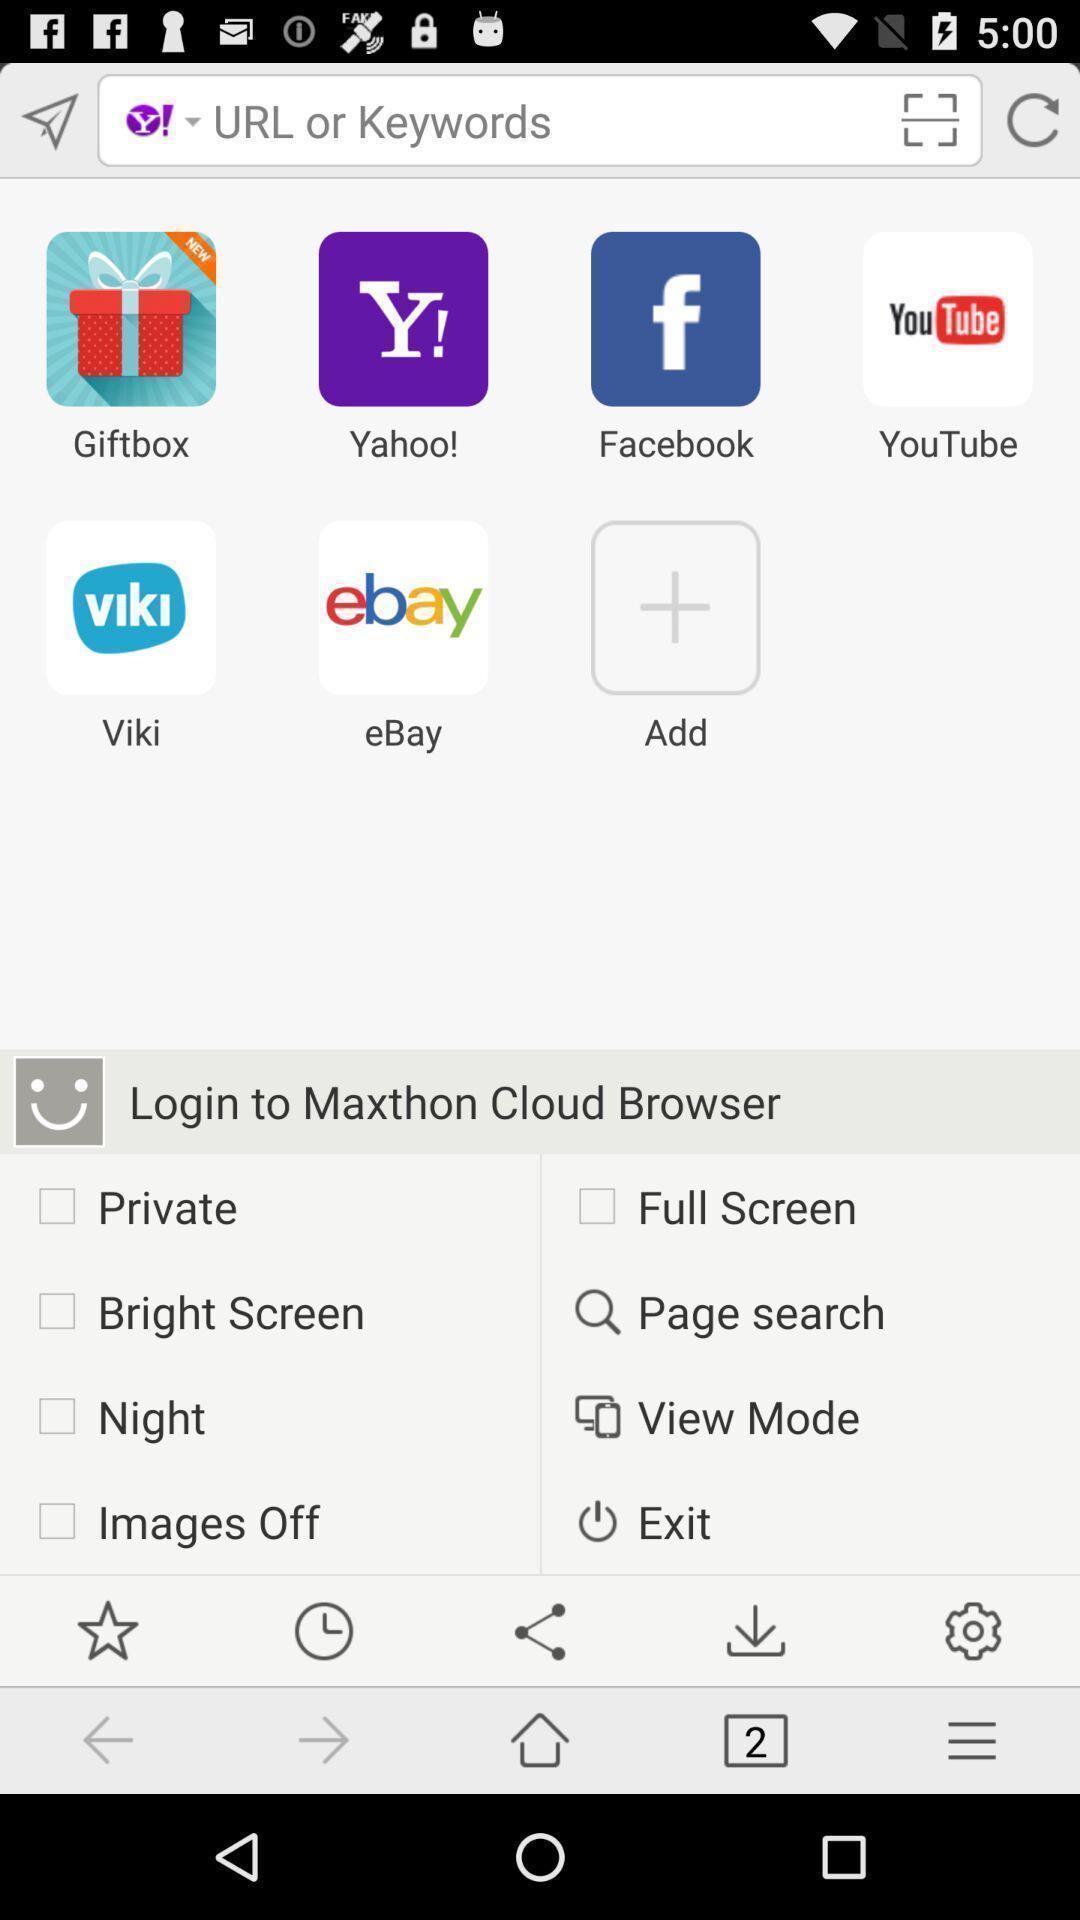Explain the elements present in this screenshot. Page with list of applications and with other options. 